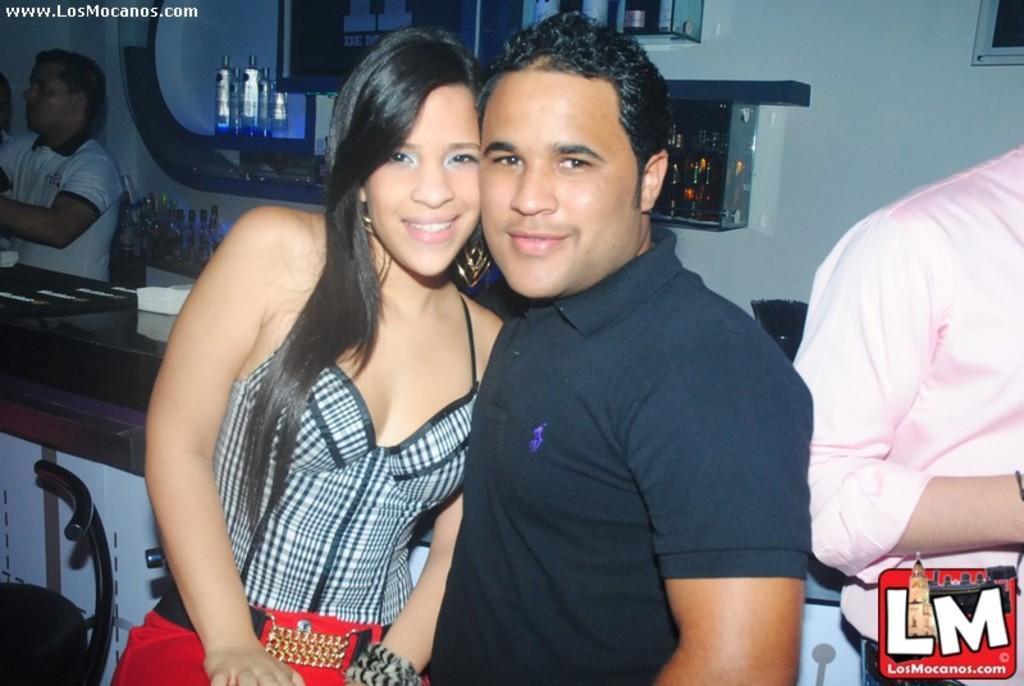Describe this image in one or two sentences. This is the picture of a room. In this image there are two persons standing and smiling. On the right side of the image there is a person standing. On the left side of the image there is a person standing and there is a chair. At the back there are bottles in the cupboard and there are tissues on the table. At the bottom right there is a logo. At the top left there is a text. 